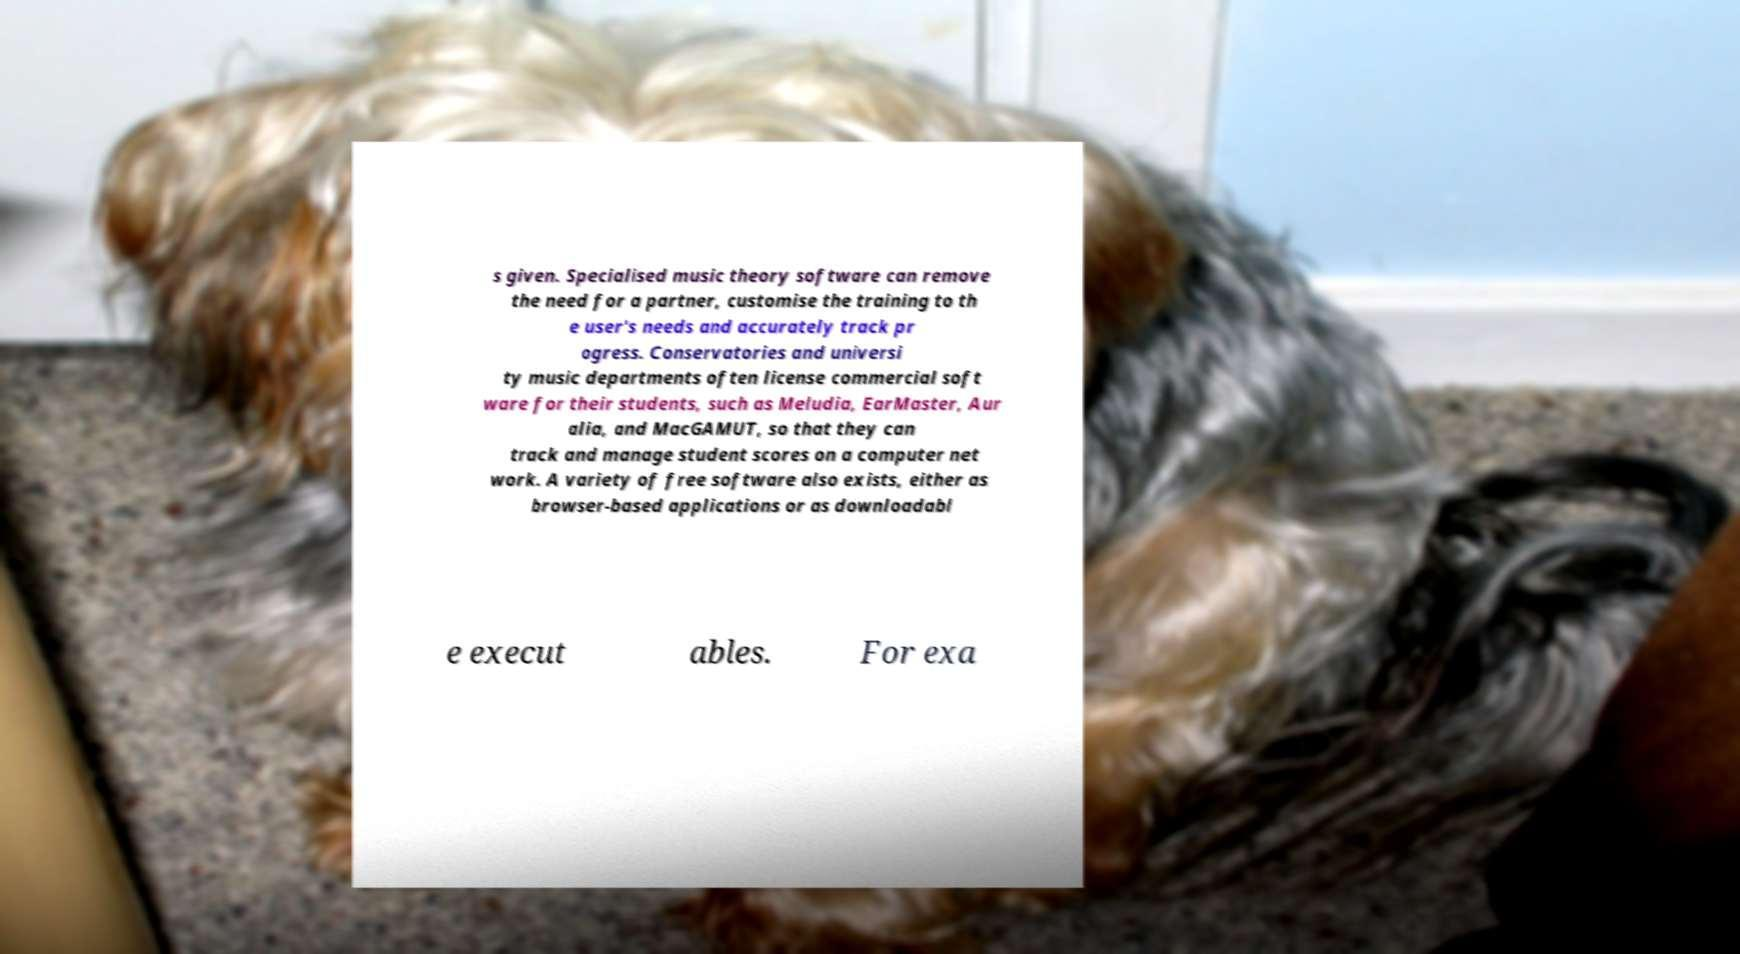Could you extract and type out the text from this image? s given. Specialised music theory software can remove the need for a partner, customise the training to th e user's needs and accurately track pr ogress. Conservatories and universi ty music departments often license commercial soft ware for their students, such as Meludia, EarMaster, Aur alia, and MacGAMUT, so that they can track and manage student scores on a computer net work. A variety of free software also exists, either as browser-based applications or as downloadabl e execut ables. For exa 